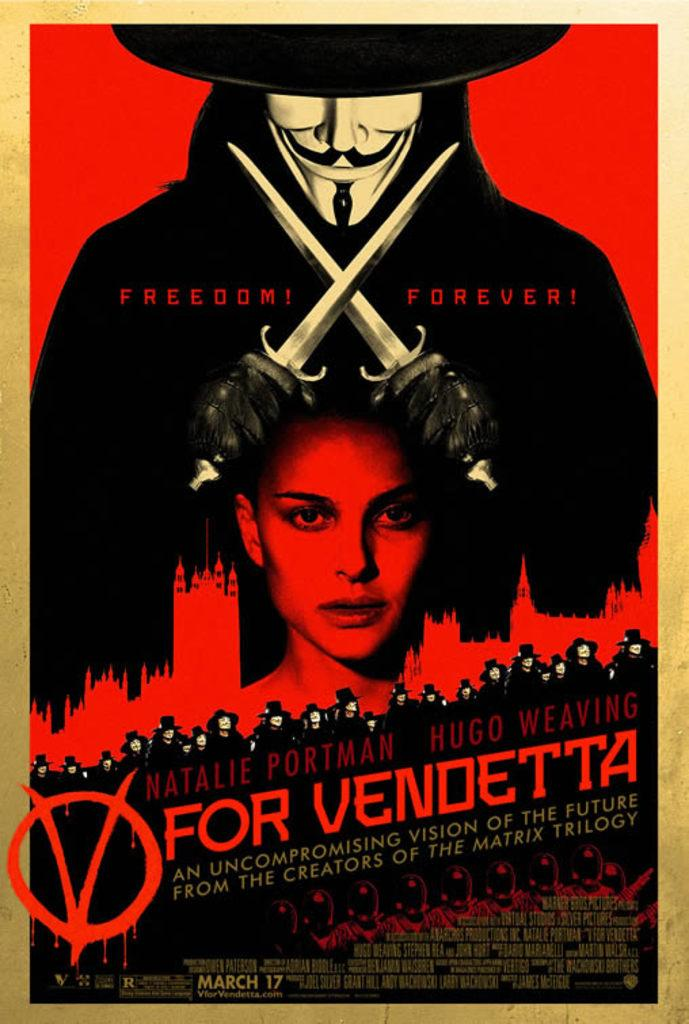<image>
Provide a brief description of the given image. A movie poster claming "Freedom! Forever!" for the movie V for Vendetta. 